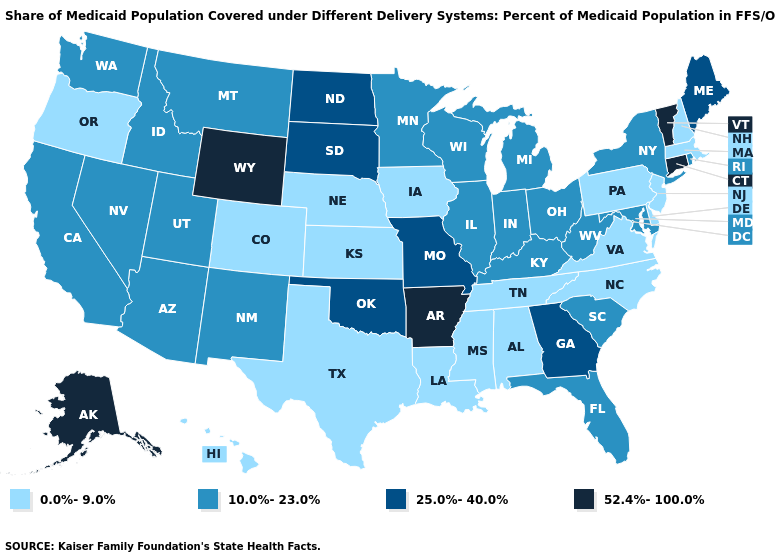Which states have the lowest value in the Northeast?
Write a very short answer. Massachusetts, New Hampshire, New Jersey, Pennsylvania. Which states hav the highest value in the South?
Answer briefly. Arkansas. Name the states that have a value in the range 25.0%-40.0%?
Write a very short answer. Georgia, Maine, Missouri, North Dakota, Oklahoma, South Dakota. Among the states that border Rhode Island , which have the highest value?
Keep it brief. Connecticut. Name the states that have a value in the range 52.4%-100.0%?
Quick response, please. Alaska, Arkansas, Connecticut, Vermont, Wyoming. Among the states that border Missouri , does Arkansas have the highest value?
Concise answer only. Yes. What is the value of South Dakota?
Keep it brief. 25.0%-40.0%. Does Arkansas have the lowest value in the South?
Give a very brief answer. No. What is the lowest value in the West?
Answer briefly. 0.0%-9.0%. Does New York have a higher value than Texas?
Keep it brief. Yes. Name the states that have a value in the range 10.0%-23.0%?
Keep it brief. Arizona, California, Florida, Idaho, Illinois, Indiana, Kentucky, Maryland, Michigan, Minnesota, Montana, Nevada, New Mexico, New York, Ohio, Rhode Island, South Carolina, Utah, Washington, West Virginia, Wisconsin. Name the states that have a value in the range 52.4%-100.0%?
Short answer required. Alaska, Arkansas, Connecticut, Vermont, Wyoming. Name the states that have a value in the range 52.4%-100.0%?
Keep it brief. Alaska, Arkansas, Connecticut, Vermont, Wyoming. Does Alaska have the highest value in the USA?
Keep it brief. Yes. Among the states that border Maryland , does Delaware have the lowest value?
Write a very short answer. Yes. 